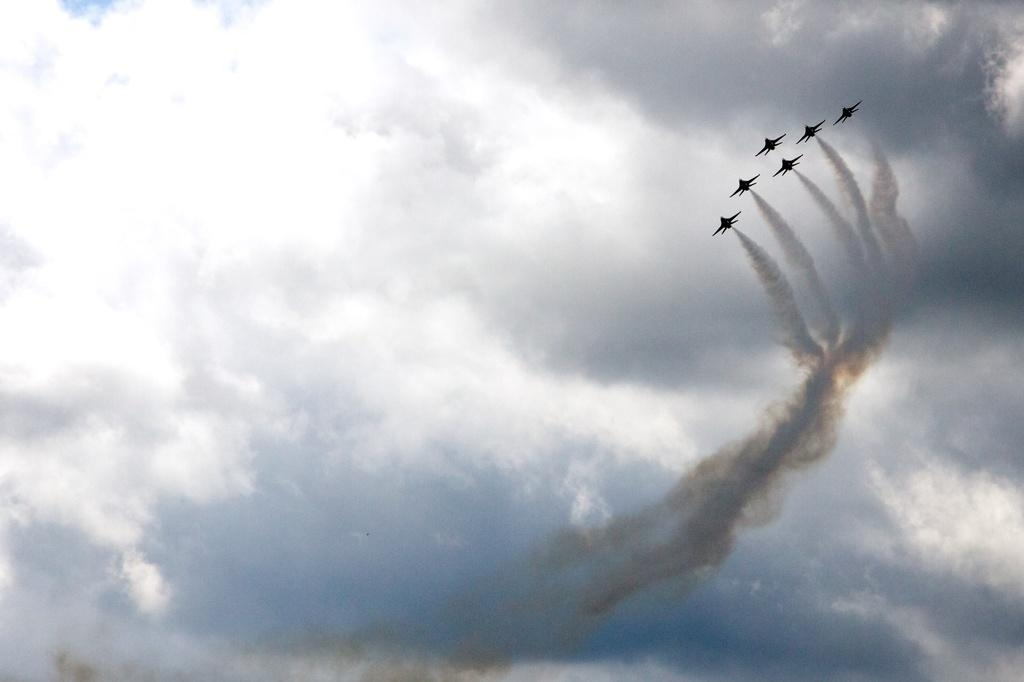What is happening in the image? There are airplanes flying in the image. What can be seen in the sky in the image? There is smoke visible in the image, and clouds are present in the sky. What is the background of the image? The sky is visible in the background of the image. How many people are walking with a basket in the image? There are no people walking with a basket in the image; it only features airplanes flying and smoke in the sky. 